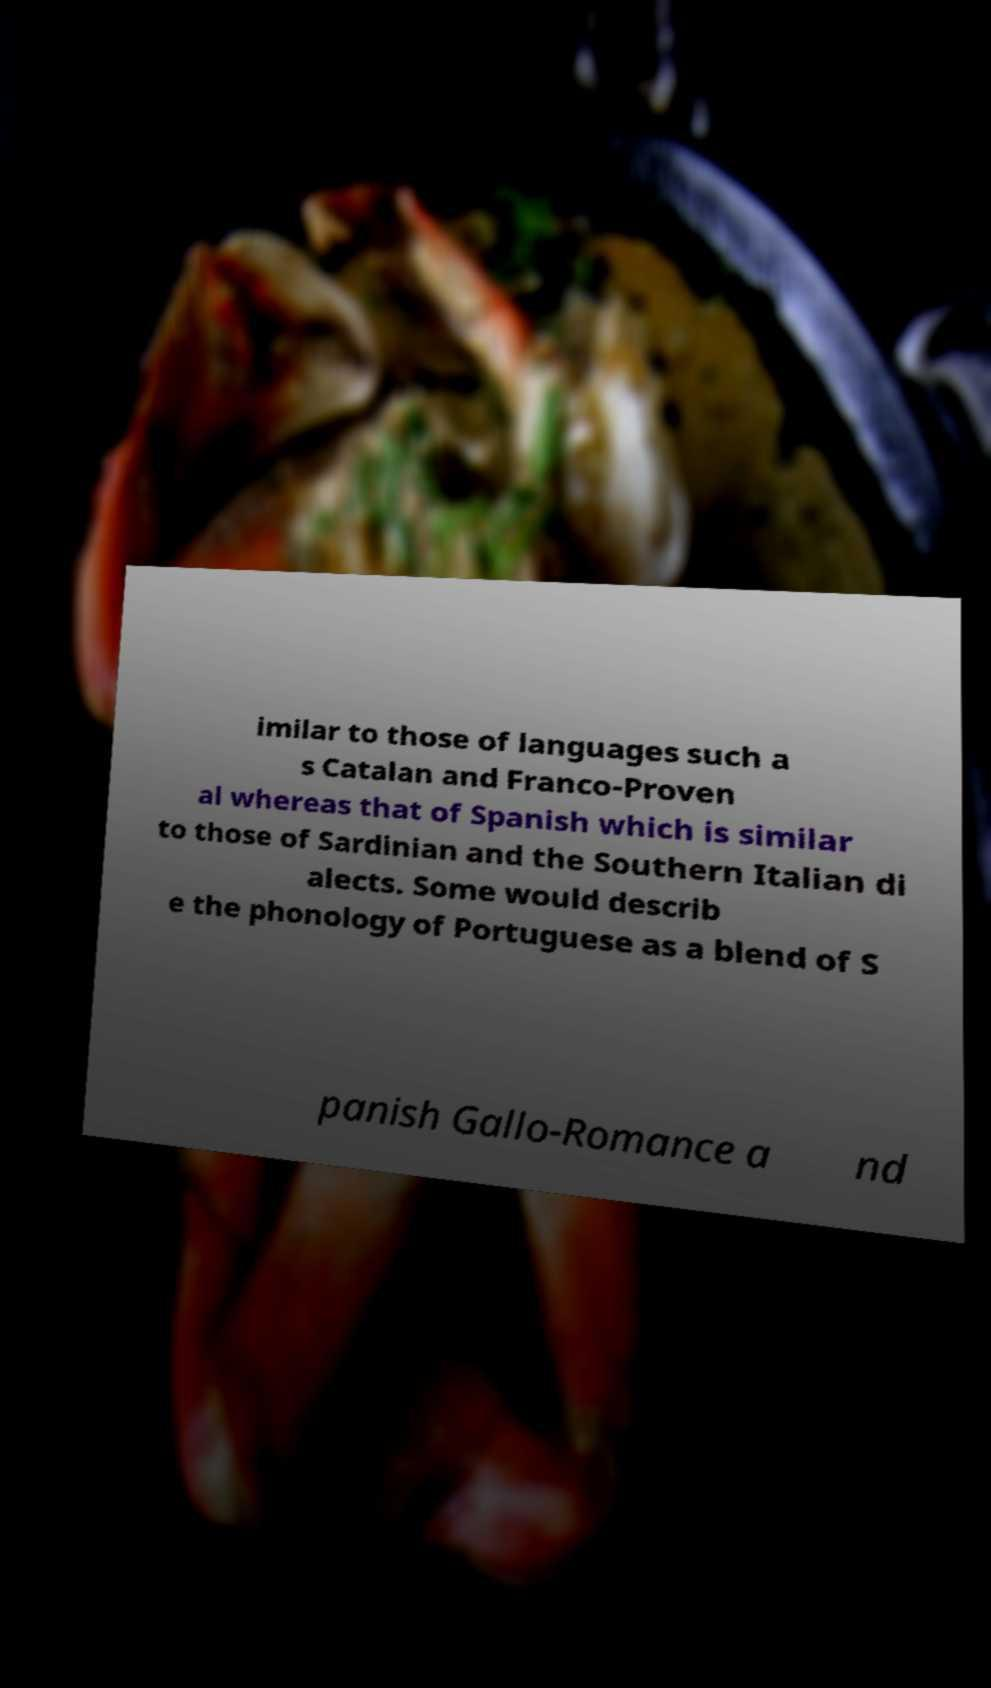Can you read and provide the text displayed in the image?This photo seems to have some interesting text. Can you extract and type it out for me? imilar to those of languages such a s Catalan and Franco-Proven al whereas that of Spanish which is similar to those of Sardinian and the Southern Italian di alects. Some would describ e the phonology of Portuguese as a blend of S panish Gallo-Romance a nd 